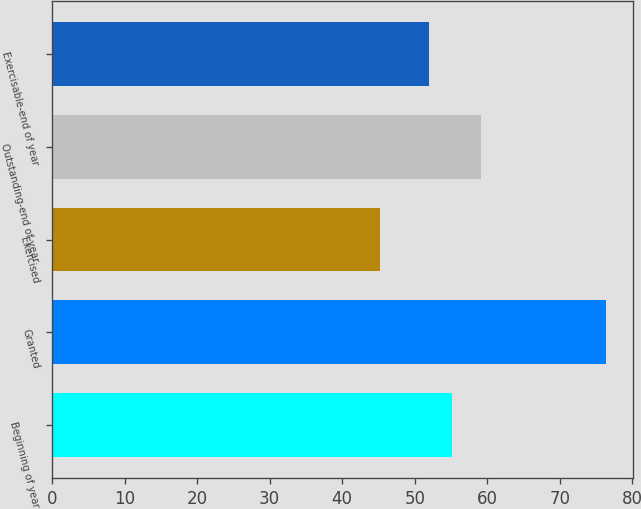Convert chart to OTSL. <chart><loc_0><loc_0><loc_500><loc_500><bar_chart><fcel>Beginning of year<fcel>Granted<fcel>Exercised<fcel>Outstanding-end of year<fcel>Exercisable-end of year<nl><fcel>55.1<fcel>76.32<fcel>45.22<fcel>59.2<fcel>51.99<nl></chart> 